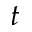<formula> <loc_0><loc_0><loc_500><loc_500>t</formula> 